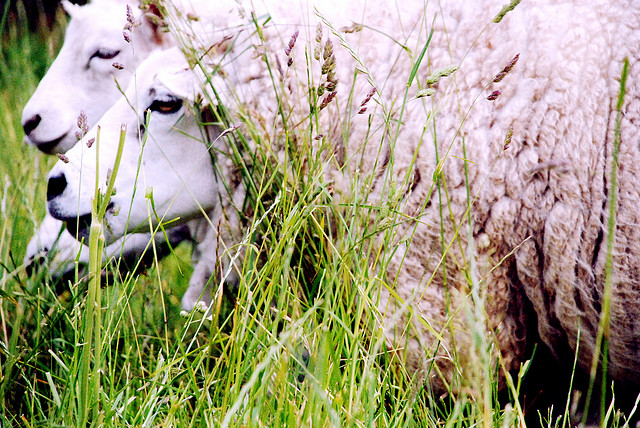<image>Which lamb is spotted? I don't know which lamb is spotted. It appears to be neither. Which lamb is spotted? I don't know which lamb is spotted. None of the lambs seem to have spots. 